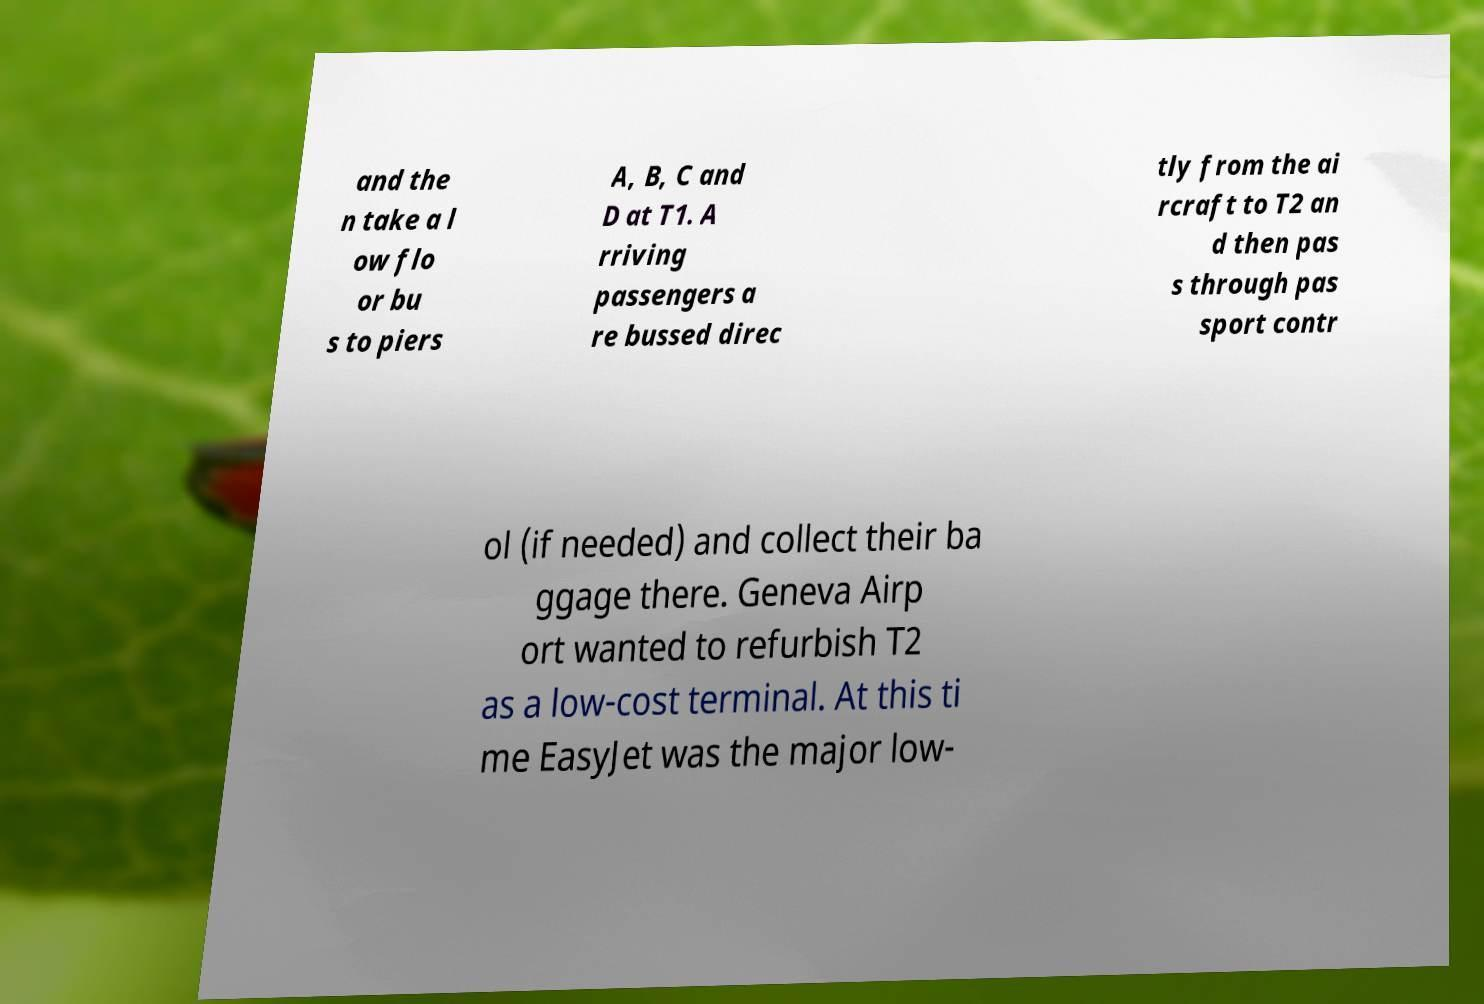Please read and relay the text visible in this image. What does it say? and the n take a l ow flo or bu s to piers A, B, C and D at T1. A rriving passengers a re bussed direc tly from the ai rcraft to T2 an d then pas s through pas sport contr ol (if needed) and collect their ba ggage there. Geneva Airp ort wanted to refurbish T2 as a low-cost terminal. At this ti me EasyJet was the major low- 